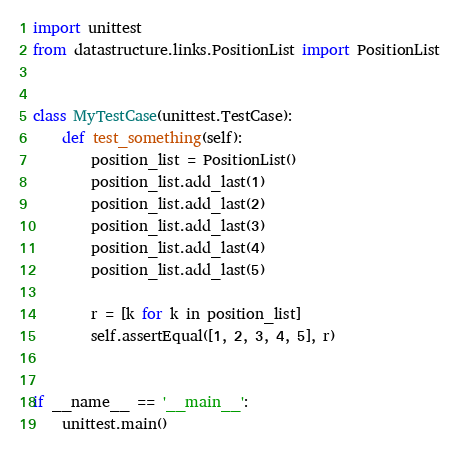Convert code to text. <code><loc_0><loc_0><loc_500><loc_500><_Python_>import unittest
from datastructure.links.PositionList import PositionList


class MyTestCase(unittest.TestCase):
    def test_something(self):
        position_list = PositionList()
        position_list.add_last(1)
        position_list.add_last(2)
        position_list.add_last(3)
        position_list.add_last(4)
        position_list.add_last(5)

        r = [k for k in position_list]
        self.assertEqual([1, 2, 3, 4, 5], r)


if __name__ == '__main__':
    unittest.main()
</code> 